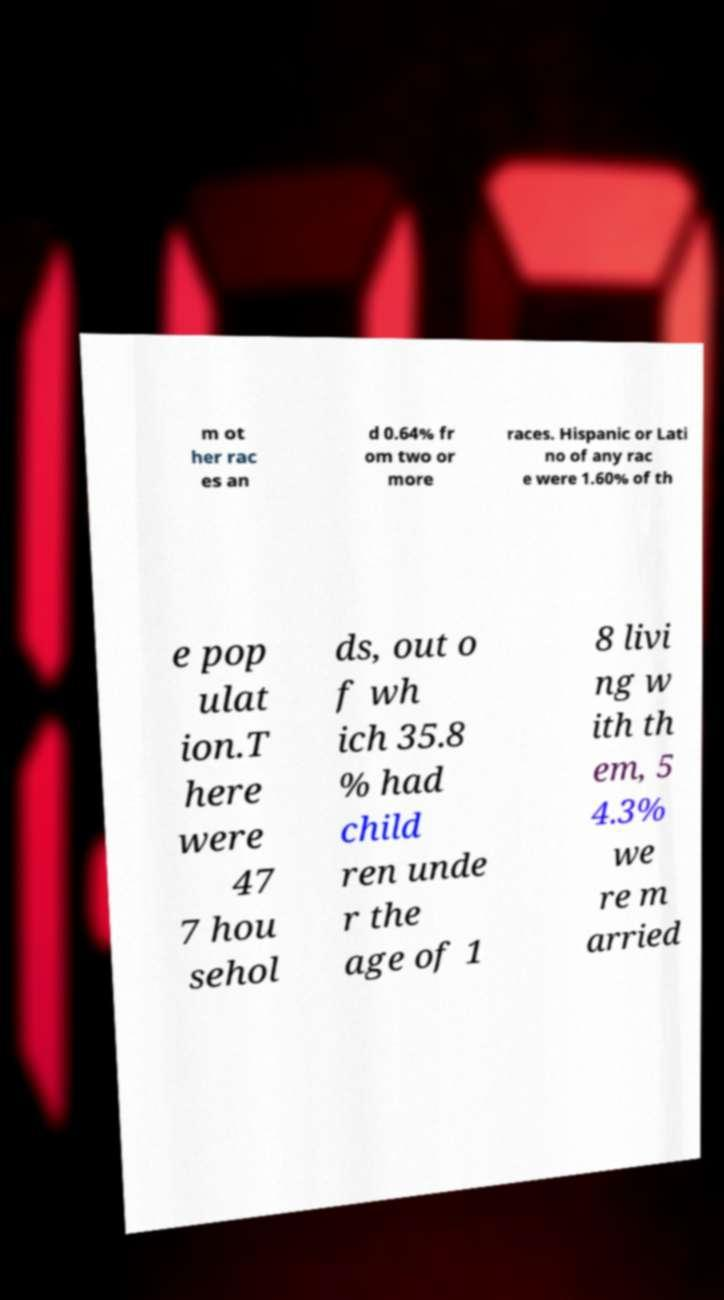Can you accurately transcribe the text from the provided image for me? m ot her rac es an d 0.64% fr om two or more races. Hispanic or Lati no of any rac e were 1.60% of th e pop ulat ion.T here were 47 7 hou sehol ds, out o f wh ich 35.8 % had child ren unde r the age of 1 8 livi ng w ith th em, 5 4.3% we re m arried 